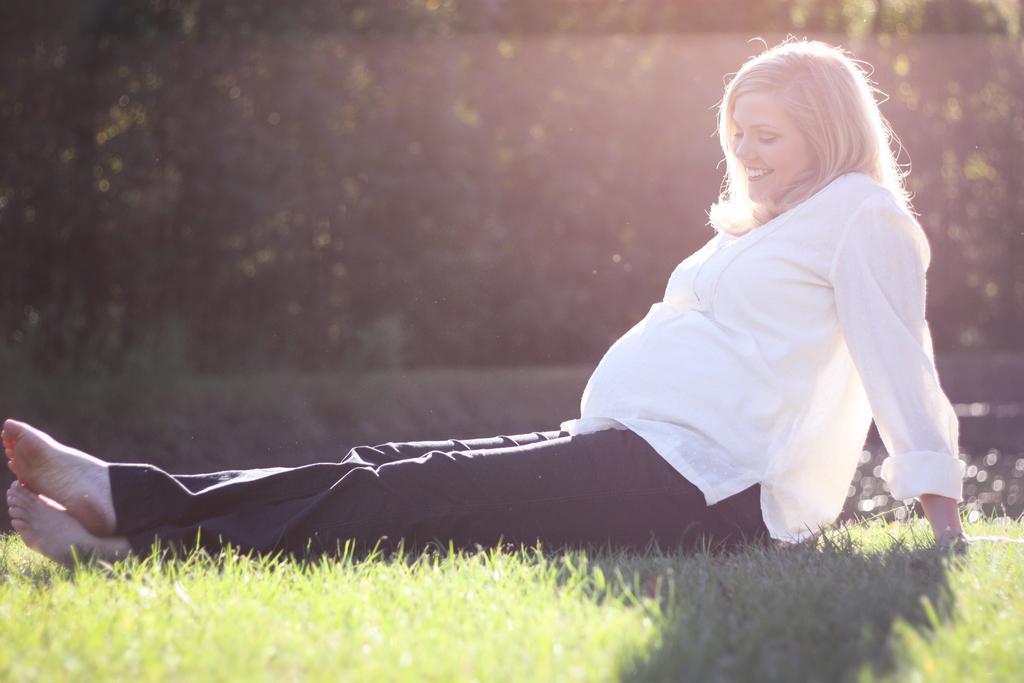Can you describe this image briefly? In this image there is pregnant lady sitting on grass and smiling beside her there are so many trees. 